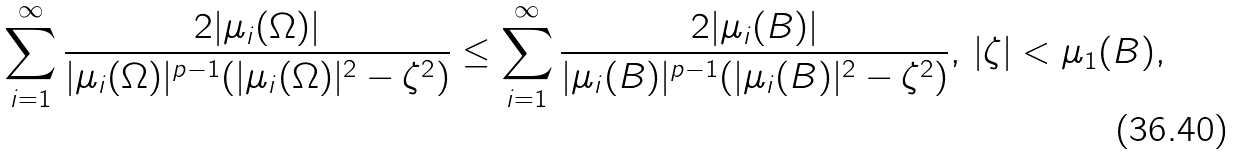<formula> <loc_0><loc_0><loc_500><loc_500>\sum _ { i = 1 } ^ { \infty } \frac { 2 | \mu _ { i } ( \Omega ) | } { | \mu _ { i } ( \Omega ) | ^ { p - 1 } ( | \mu _ { i } ( \Omega ) | ^ { 2 } - \zeta ^ { 2 } ) } \leq \sum _ { i = 1 } ^ { \infty } \frac { 2 | \mu _ { i } ( B ) | } { | \mu _ { i } ( B ) | ^ { p - 1 } ( | \mu _ { i } ( B ) | ^ { 2 } - \zeta ^ { 2 } ) } , \, | \zeta | < \mu _ { 1 } ( B ) ,</formula> 